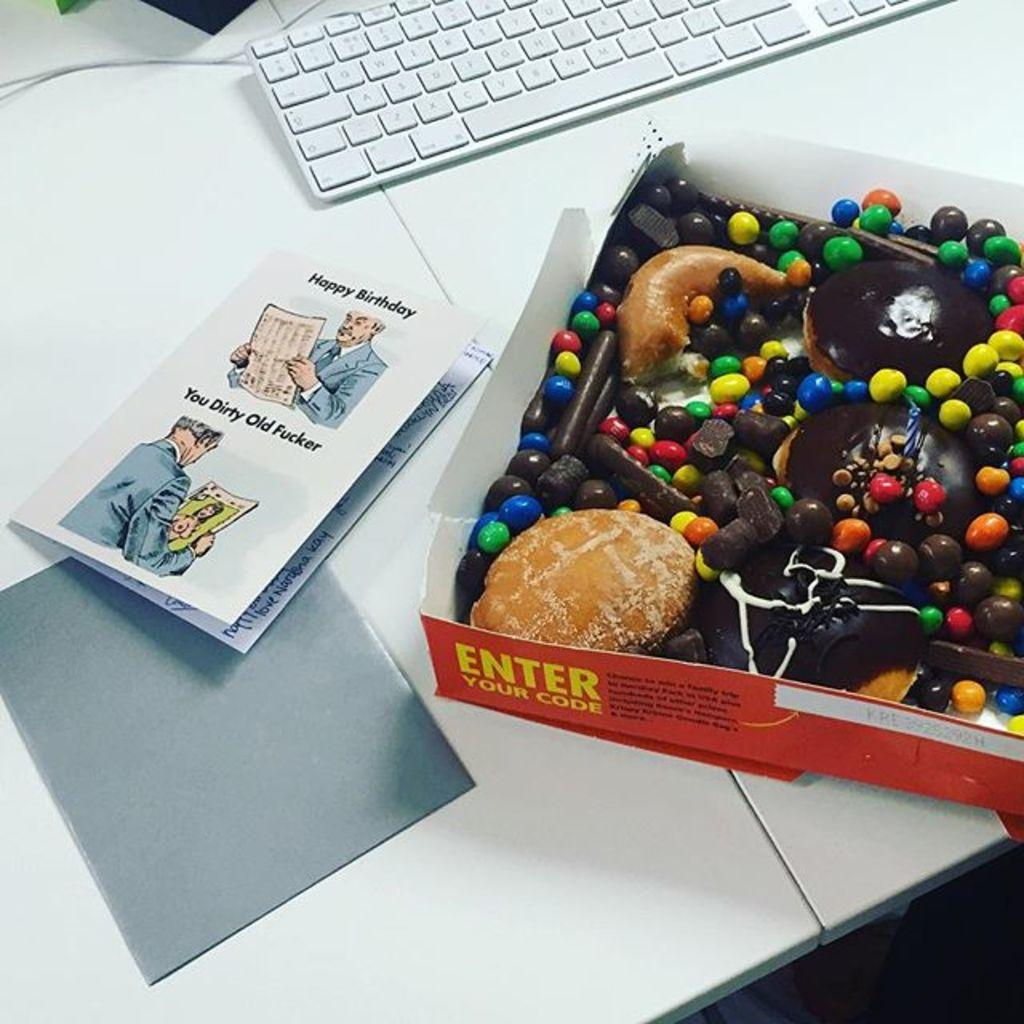<image>
Create a compact narrative representing the image presented. A box with chocolate inside it and words asking for a code to be entered on the outside. 